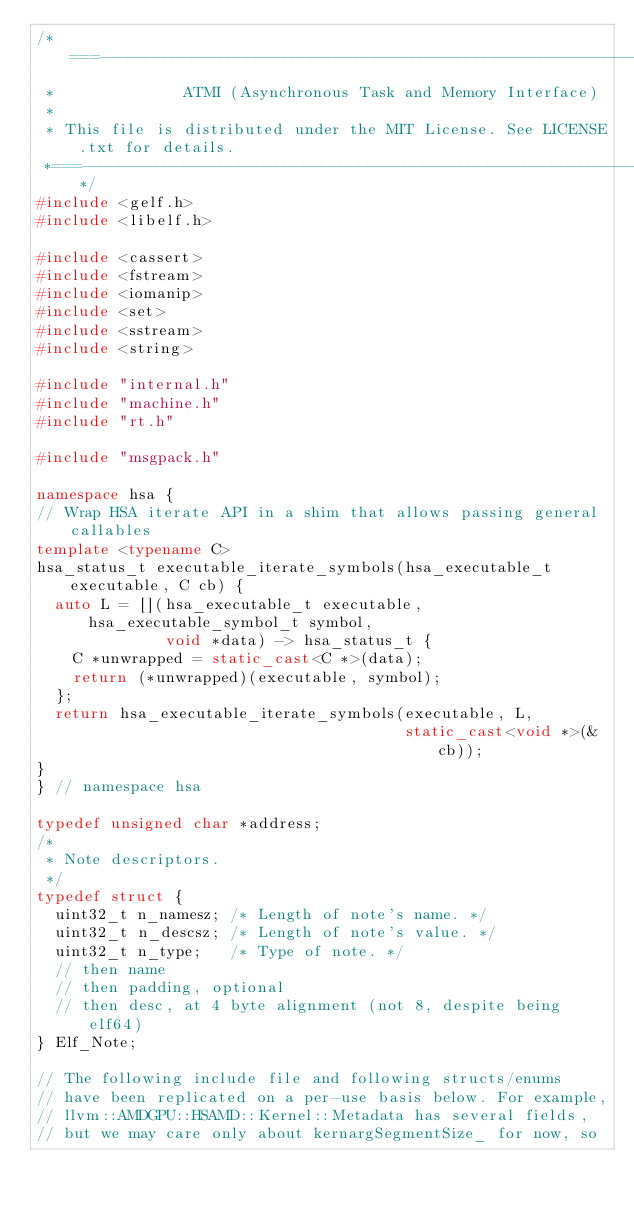<code> <loc_0><loc_0><loc_500><loc_500><_C++_>/*===--------------------------------------------------------------------------
 *              ATMI (Asynchronous Task and Memory Interface)
 *
 * This file is distributed under the MIT License. See LICENSE.txt for details.
 *===------------------------------------------------------------------------*/
#include <gelf.h>
#include <libelf.h>

#include <cassert>
#include <fstream>
#include <iomanip>
#include <set>
#include <sstream>
#include <string>

#include "internal.h"
#include "machine.h"
#include "rt.h"

#include "msgpack.h"

namespace hsa {
// Wrap HSA iterate API in a shim that allows passing general callables
template <typename C>
hsa_status_t executable_iterate_symbols(hsa_executable_t executable, C cb) {
  auto L = [](hsa_executable_t executable, hsa_executable_symbol_t symbol,
              void *data) -> hsa_status_t {
    C *unwrapped = static_cast<C *>(data);
    return (*unwrapped)(executable, symbol);
  };
  return hsa_executable_iterate_symbols(executable, L,
                                        static_cast<void *>(&cb));
}
} // namespace hsa

typedef unsigned char *address;
/*
 * Note descriptors.
 */
typedef struct {
  uint32_t n_namesz; /* Length of note's name. */
  uint32_t n_descsz; /* Length of note's value. */
  uint32_t n_type;   /* Type of note. */
  // then name
  // then padding, optional
  // then desc, at 4 byte alignment (not 8, despite being elf64)
} Elf_Note;

// The following include file and following structs/enums
// have been replicated on a per-use basis below. For example,
// llvm::AMDGPU::HSAMD::Kernel::Metadata has several fields,
// but we may care only about kernargSegmentSize_ for now, so</code> 